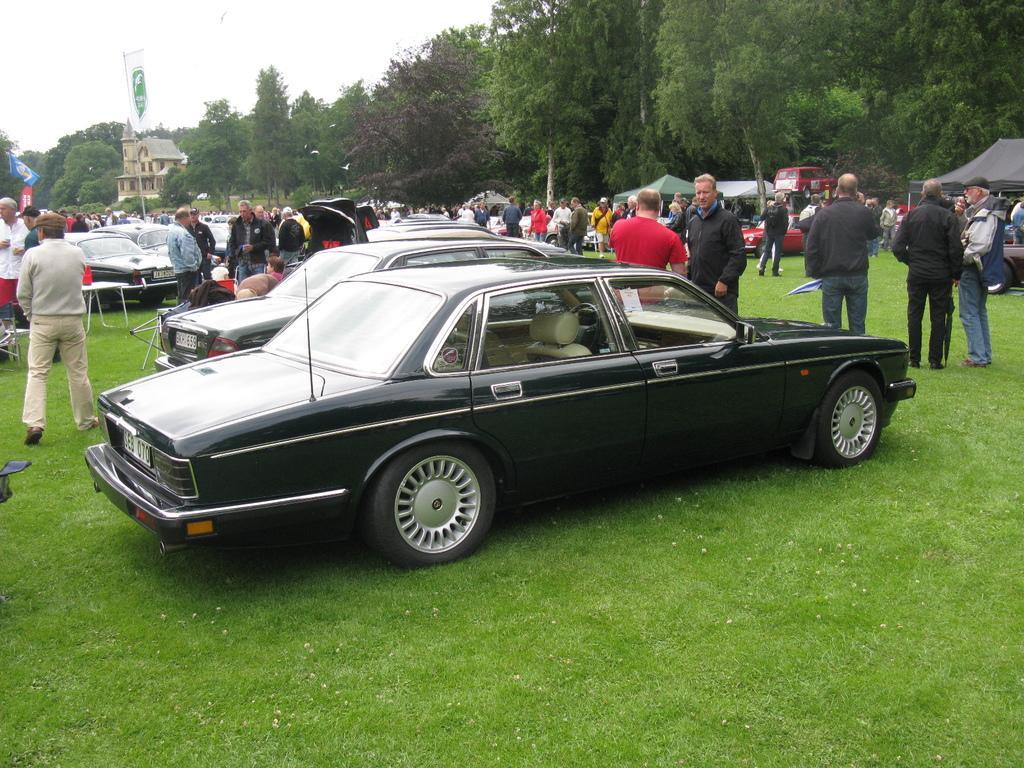In one or two sentences, can you explain what this image depicts? In this image there are so many cars parked on the ground. There are so many people around the cars. In the background there is a building and trees beside it. On the right side there are tents under which there are few people. In the middle there is a flag. 